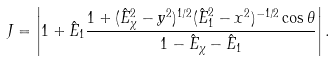<formula> <loc_0><loc_0><loc_500><loc_500>J = \left | 1 + \hat { E } _ { 1 } \frac { 1 + ( \hat { E } _ { \chi } ^ { 2 } - y ^ { 2 } ) ^ { 1 / 2 } ( \hat { E } _ { 1 } ^ { 2 } - x ^ { 2 } ) ^ { - 1 / 2 } \cos \theta } { 1 - \hat { E } _ { \chi } - \hat { E } _ { 1 } } \right | .</formula> 